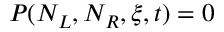Convert formula to latex. <formula><loc_0><loc_0><loc_500><loc_500>P ( N _ { L } , N _ { R } , \xi , t ) = 0</formula> 